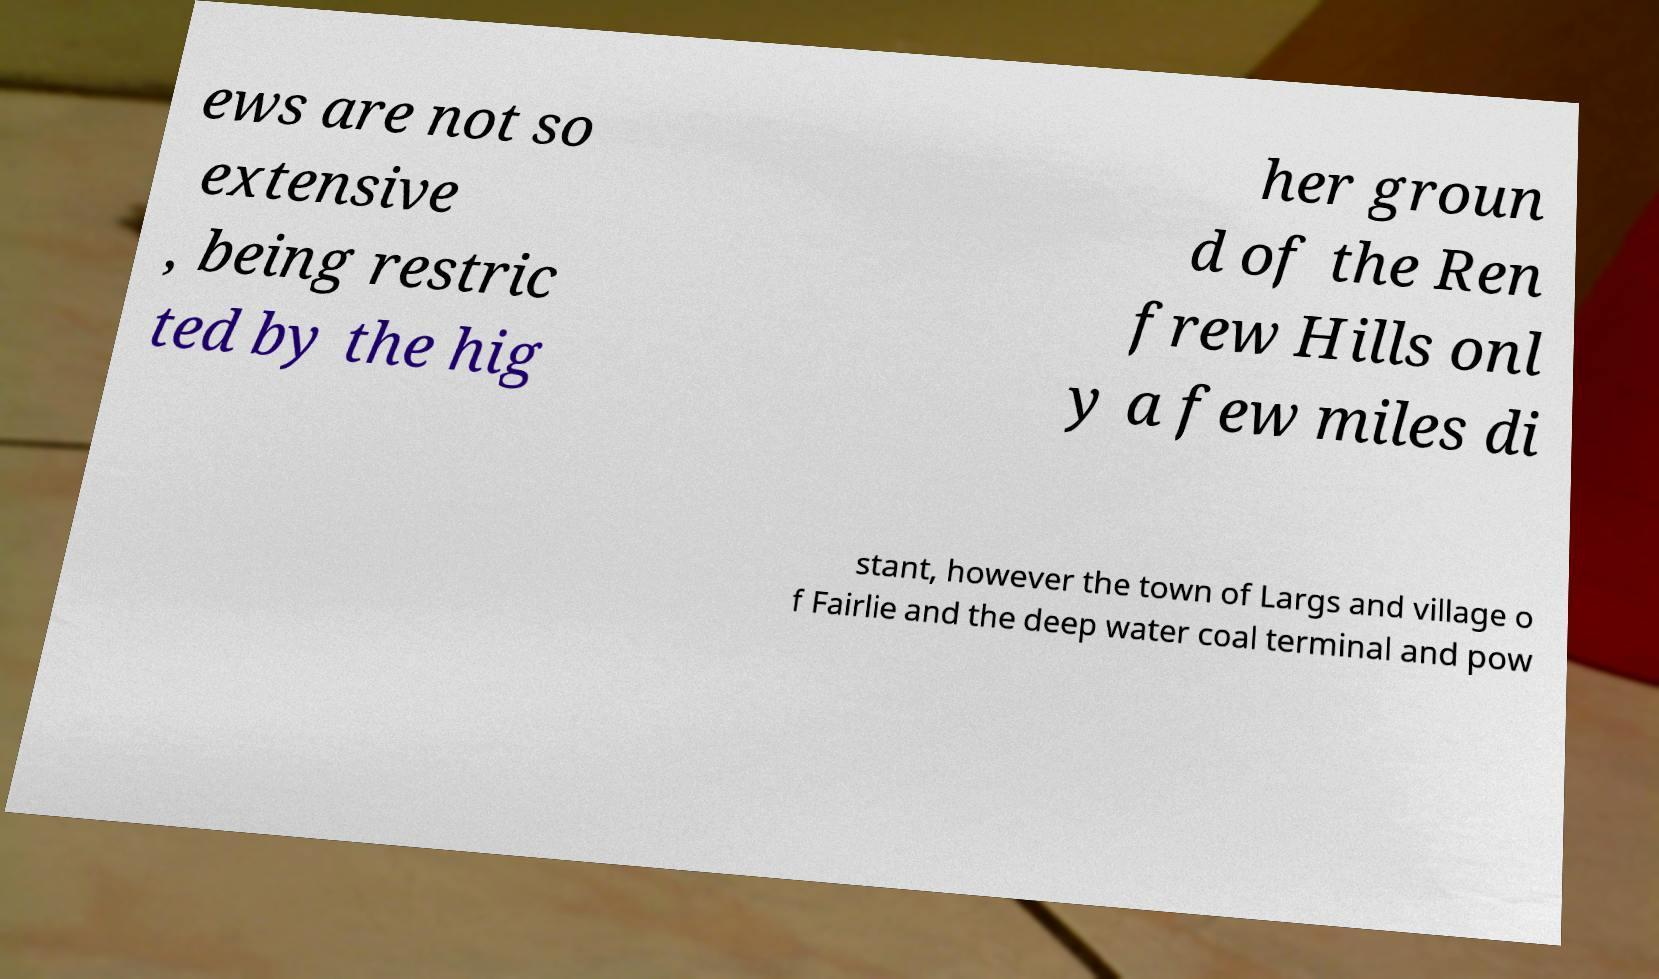Could you extract and type out the text from this image? ews are not so extensive , being restric ted by the hig her groun d of the Ren frew Hills onl y a few miles di stant, however the town of Largs and village o f Fairlie and the deep water coal terminal and pow 